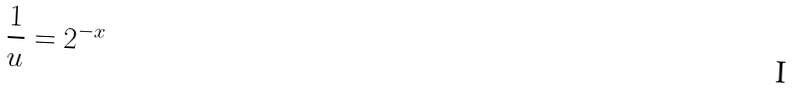Convert formula to latex. <formula><loc_0><loc_0><loc_500><loc_500>\frac { 1 } { u } = 2 ^ { - x }</formula> 